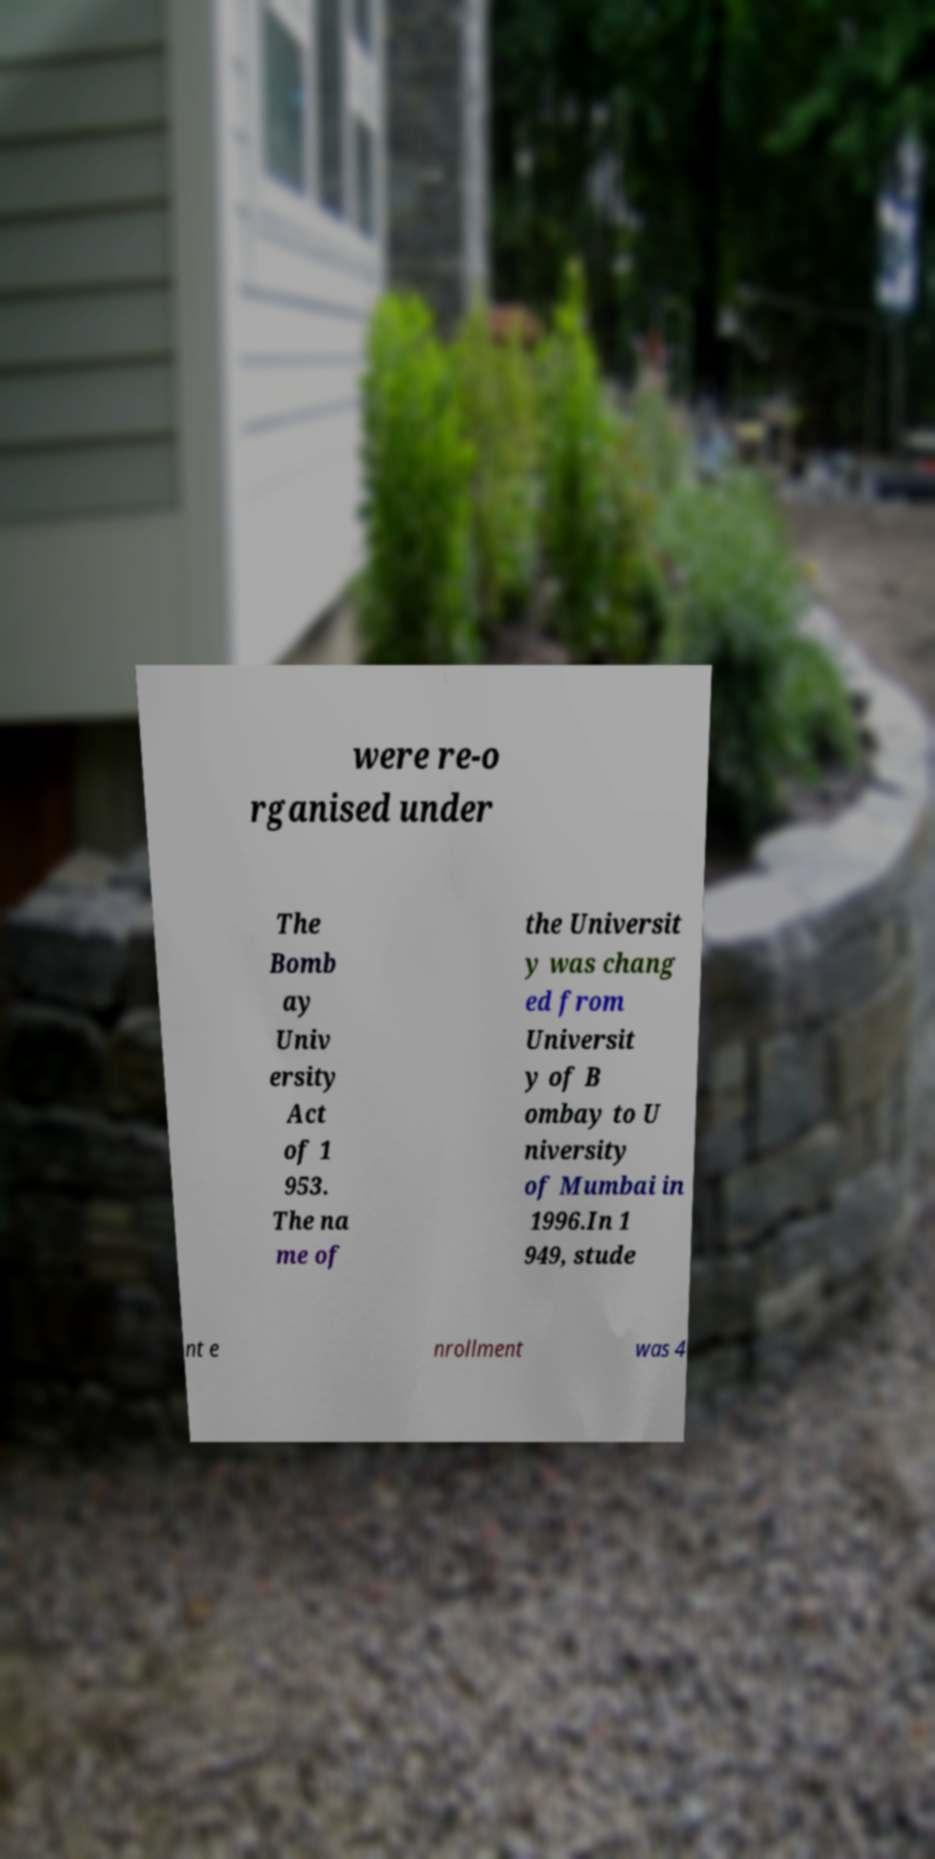Can you read and provide the text displayed in the image?This photo seems to have some interesting text. Can you extract and type it out for me? were re-o rganised under The Bomb ay Univ ersity Act of 1 953. The na me of the Universit y was chang ed from Universit y of B ombay to U niversity of Mumbai in 1996.In 1 949, stude nt e nrollment was 4 